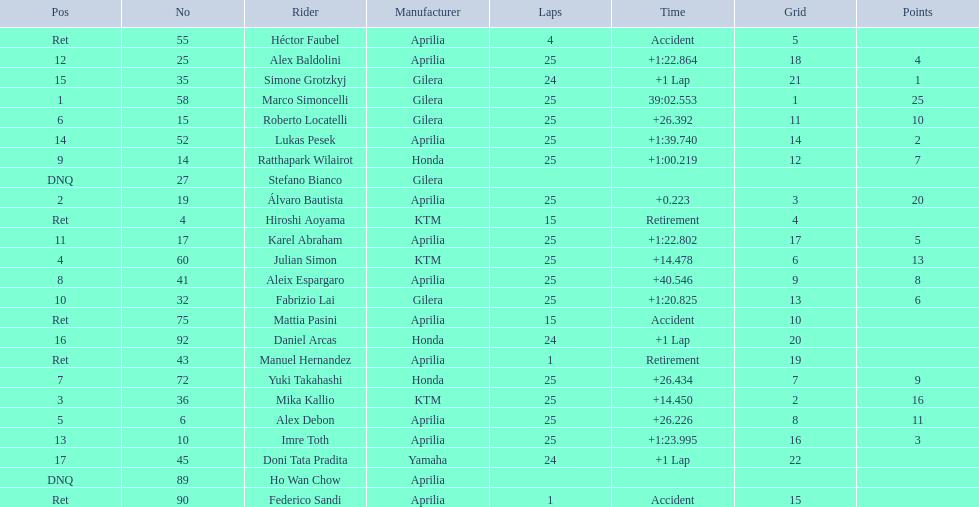Who are all the riders? Marco Simoncelli, Álvaro Bautista, Mika Kallio, Julian Simon, Alex Debon, Roberto Locatelli, Yuki Takahashi, Aleix Espargaro, Ratthapark Wilairot, Fabrizio Lai, Karel Abraham, Alex Baldolini, Imre Toth, Lukas Pesek, Simone Grotzkyj, Daniel Arcas, Doni Tata Pradita, Hiroshi Aoyama, Mattia Pasini, Héctor Faubel, Federico Sandi, Manuel Hernandez, Stefano Bianco, Ho Wan Chow. Which held rank 1? Marco Simoncelli. 